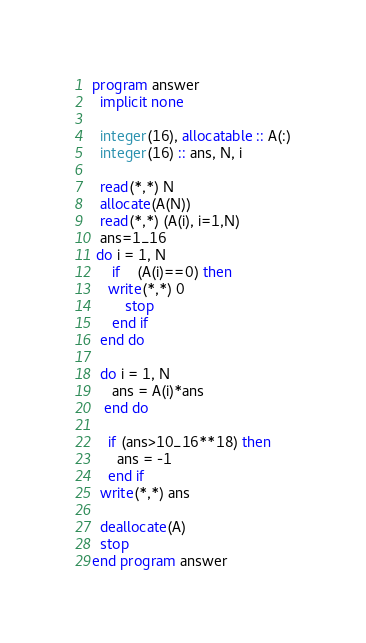Convert code to text. <code><loc_0><loc_0><loc_500><loc_500><_FORTRAN_>program answer
  implicit none

  integer(16), allocatable :: A(:)
  integer(16) :: ans, N, i

  read(*,*) N
  allocate(A(N))
  read(*,*) (A(i), i=1,N)
  ans=1_16
 do i = 1, N
     if	(A(i)==0) then
	write(*,*) 0
      	stop
     end if
  end do

  do i = 1, N
     ans = A(i)*ans
   end do

    if (ans>10_16**18) then
      ans = -1
    end if
  write(*,*) ans

  deallocate(A)
  stop
end program answer
</code> 